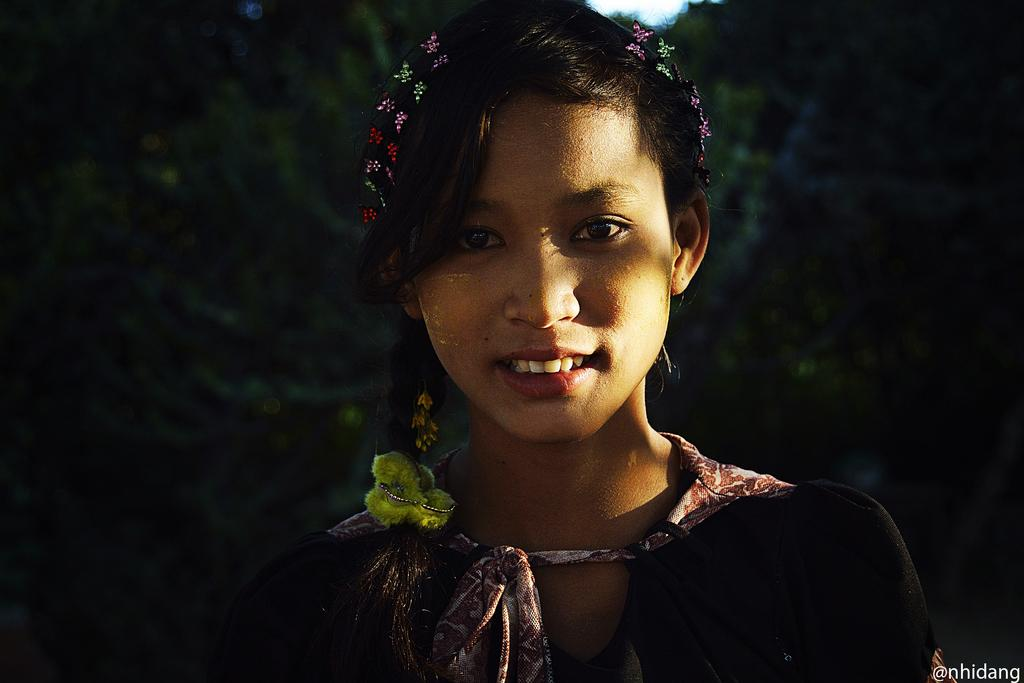Who is the main subject in the image? There is a girl in the front of the image. What can be seen in the background of the image? There are trees in the background of the image. Where is the text located in the image? The text is at the right bottom of the image. What type of lace is the girl wearing in the image? There is no lace visible on the girl in the image. How many deer can be seen in the image? There are no deer present in the image. 